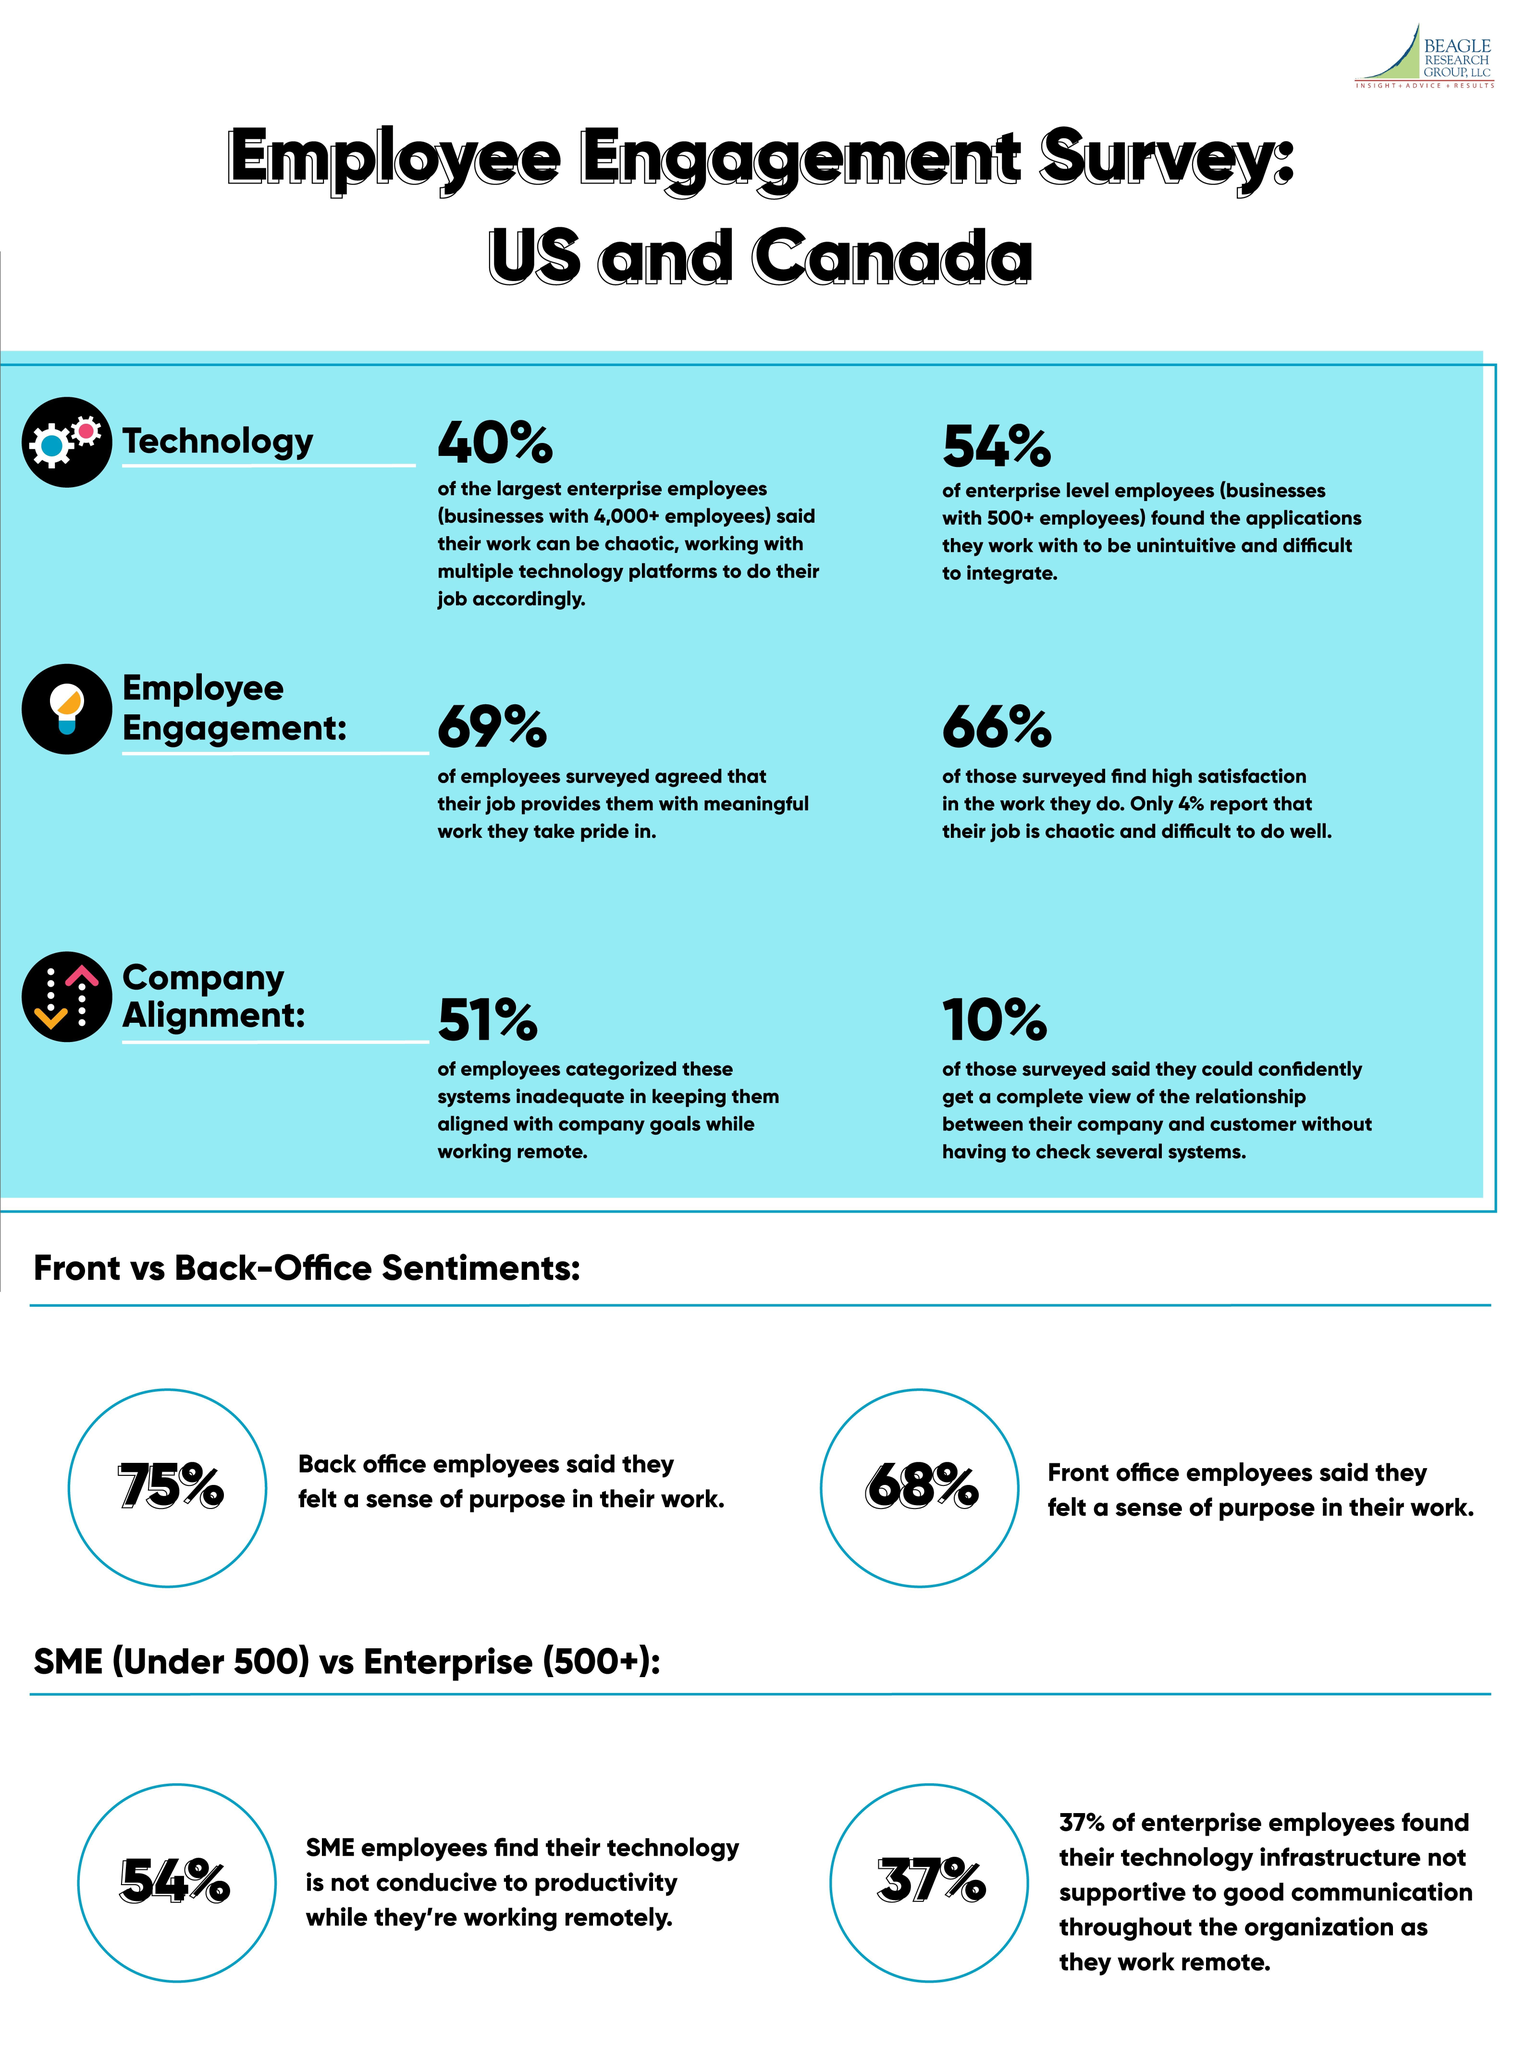What percentage of front office staffs do not felt an objective in their work?
Answer the question with a short phrase. 32 What percentage of Back office staffs do not felt an objective in their work? 25 What percentage of employees believe the technology that they are using is up to the mark ? 46 What percentage of employees feel proud about their work? 69% What percentage of employees believe the technology they use to interact with each other is doing good? 63 What percentage of employees feel content about their work? 66% 